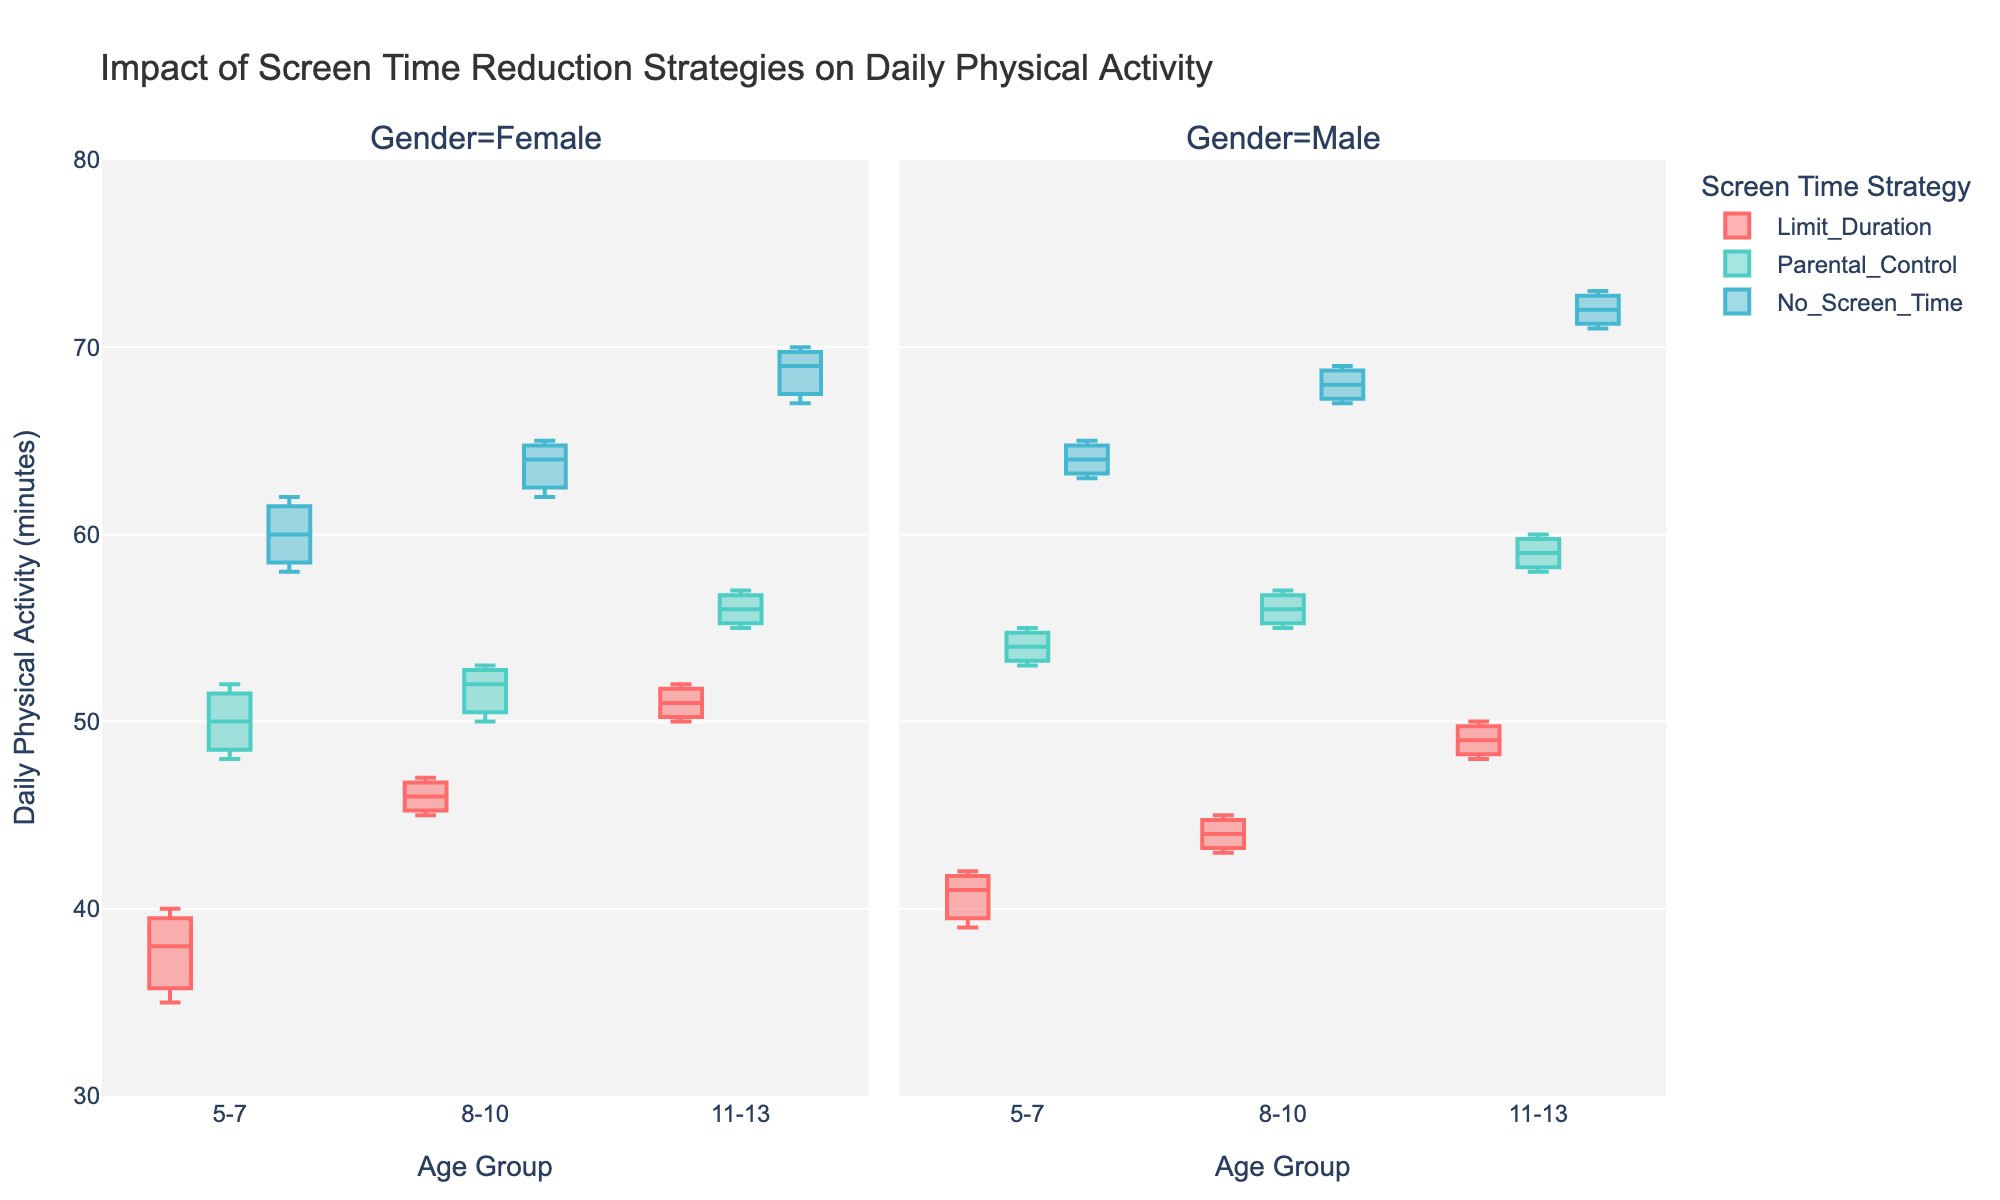What is the title of the figure? To find the title, look at the top of the figure, where it is clearly mentioned.
Answer: Impact of Screen Time Reduction Strategies on Daily Physical Activity Which screen time reduction strategy leads to the highest physical activity in children aged 5-7? Check the box plots for the 5-7 age group across all strategies and see which has the highest median value.
Answer: No Screen Time Among males aged 11-13, which strategy shows the lowest minimum value for daily physical activity? Look at the box plot for males aged 11-13 for the lowest whisker (minimum value) and identify the strategy.
Answer: Limit Duration How does the median daily physical activity for females aged 8-10 using Parental Control compare to females aged 11-13 using Parental Control? Identify the median line within the boxes for females in both age groups using Parental Control and compare the two.
Answer: Higher for ages 11-13 What is the range of daily physical activity for males aged 8-10 under the No Screen Time strategy? Find the difference between the maximum and minimum whiskers for the box plot of males aged 8-10 under the No Screen Time strategy.
Answer: 67-69 minutes Which group has the smallest interquartile range (IQR) for daily physical activity under the Limit Duration strategy? Check the IQR, which is the box height, for all groups under the Limit Duration strategy, and identify the smallest.
Answer: Males aged 5-7 In the 5-7 age group, which gender shows higher variability in daily physical activity under the Parental Control strategy? Compare the spread (range and IQR) of the box plots for males and females aged 5-7 under Parental Control.
Answer: Males Is there any age group where 'Parental Control' leads to higher median daily physical activity than 'No Screen Time'? Compare the median lines within each box plot for the strategies 'Parental Control' and 'No Screen Time' across all age groups.
Answer: No Which gender, on average, seems to benefit more from a 'No Screen Time' strategy within the 8-10 age group? Compare the overall height of the boxes and whiskers to see if one gender shows higher average physical activity under 'No Screen Time'.
Answer: Males 